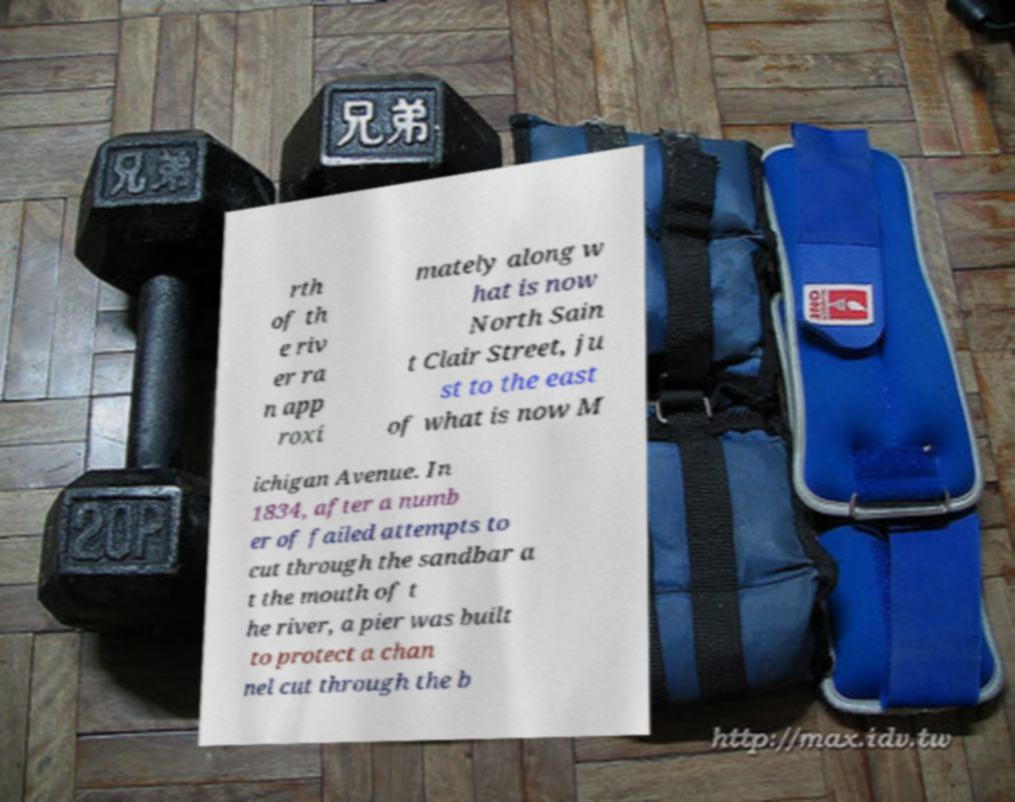Please read and relay the text visible in this image. What does it say? rth of th e riv er ra n app roxi mately along w hat is now North Sain t Clair Street, ju st to the east of what is now M ichigan Avenue. In 1834, after a numb er of failed attempts to cut through the sandbar a t the mouth of t he river, a pier was built to protect a chan nel cut through the b 